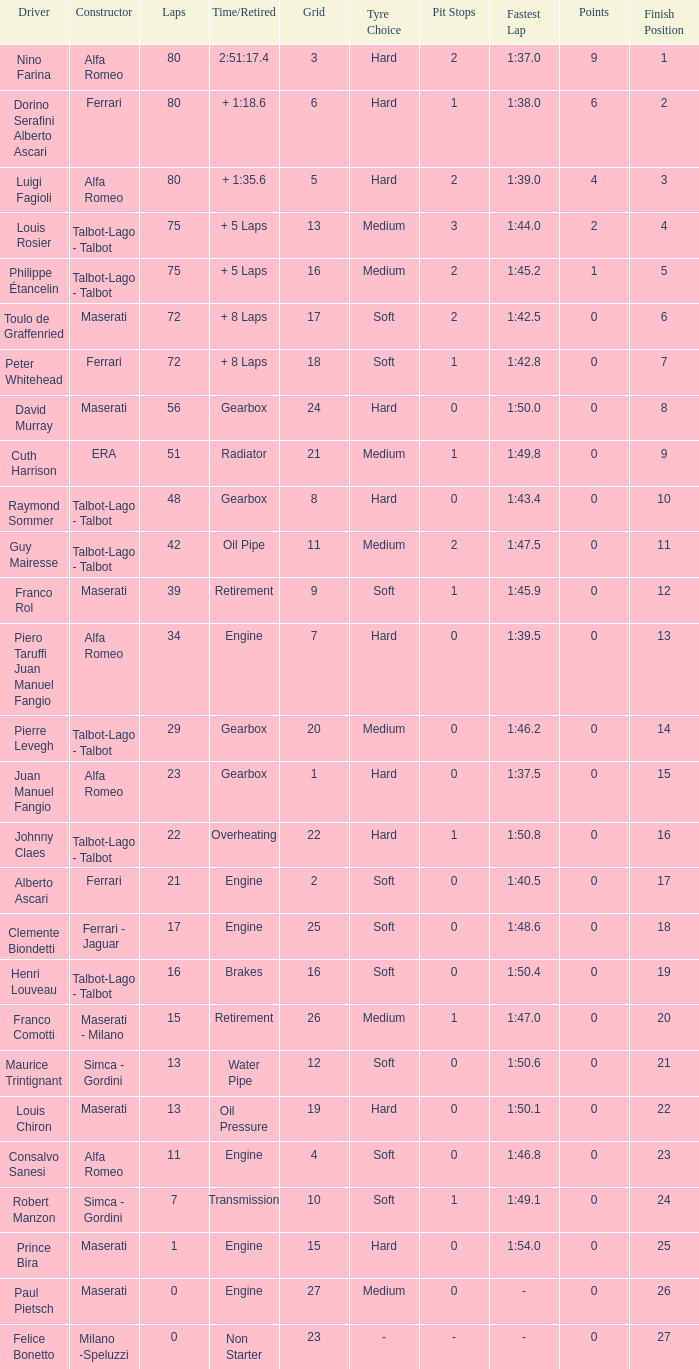Help me parse the entirety of this table. {'header': ['Driver', 'Constructor', 'Laps', 'Time/Retired', 'Grid', 'Tyre Choice', 'Pit Stops', 'Fastest Lap', 'Points', 'Finish Position'], 'rows': [['Nino Farina', 'Alfa Romeo', '80', '2:51:17.4', '3', 'Hard', '2', '1:37.0', '9', '1'], ['Dorino Serafini Alberto Ascari', 'Ferrari', '80', '+ 1:18.6', '6', 'Hard', '1', '1:38.0', '6', '2'], ['Luigi Fagioli', 'Alfa Romeo', '80', '+ 1:35.6', '5', 'Hard', '2', '1:39.0', '4', '3'], ['Louis Rosier', 'Talbot-Lago - Talbot', '75', '+ 5 Laps', '13', 'Medium', '3', '1:44.0', '2', '4'], ['Philippe Étancelin', 'Talbot-Lago - Talbot', '75', '+ 5 Laps', '16', 'Medium', '2', '1:45.2', '1', '5'], ['Toulo de Graffenried', 'Maserati', '72', '+ 8 Laps', '17', 'Soft', '2', '1:42.5', '0', '6'], ['Peter Whitehead', 'Ferrari', '72', '+ 8 Laps', '18', 'Soft', '1', '1:42.8', '0', '7'], ['David Murray', 'Maserati', '56', 'Gearbox', '24', 'Hard', '0', '1:50.0', '0', '8'], ['Cuth Harrison', 'ERA', '51', 'Radiator', '21', 'Medium', '1', '1:49.8', '0', '9'], ['Raymond Sommer', 'Talbot-Lago - Talbot', '48', 'Gearbox', '8', 'Hard', '0', '1:43.4', '0', '10'], ['Guy Mairesse', 'Talbot-Lago - Talbot', '42', 'Oil Pipe', '11', 'Medium', '2', '1:47.5', '0', '11'], ['Franco Rol', 'Maserati', '39', 'Retirement', '9', 'Soft', '1', '1:45.9', '0', '12'], ['Piero Taruffi Juan Manuel Fangio', 'Alfa Romeo', '34', 'Engine', '7', 'Hard', '0', '1:39.5', '0', '13'], ['Pierre Levegh', 'Talbot-Lago - Talbot', '29', 'Gearbox', '20', 'Medium', '0', '1:46.2', '0', '14'], ['Juan Manuel Fangio', 'Alfa Romeo', '23', 'Gearbox', '1', 'Hard', '0', '1:37.5', '0', '15'], ['Johnny Claes', 'Talbot-Lago - Talbot', '22', 'Overheating', '22', 'Hard', '1', '1:50.8', '0', '16'], ['Alberto Ascari', 'Ferrari', '21', 'Engine', '2', 'Soft', '0', '1:40.5', '0', '17'], ['Clemente Biondetti', 'Ferrari - Jaguar', '17', 'Engine', '25', 'Soft', '0', '1:48.6', '0', '18'], ['Henri Louveau', 'Talbot-Lago - Talbot', '16', 'Brakes', '16', 'Soft', '0', '1:50.4', '0', '19'], ['Franco Comotti', 'Maserati - Milano', '15', 'Retirement', '26', 'Medium', '1', '1:47.0', '0', '20'], ['Maurice Trintignant', 'Simca - Gordini', '13', 'Water Pipe', '12', 'Soft', '0', '1:50.6', '0', '21'], ['Louis Chiron', 'Maserati', '13', 'Oil Pressure', '19', 'Hard', '0', '1:50.1', '0', '22'], ['Consalvo Sanesi', 'Alfa Romeo', '11', 'Engine', '4', 'Soft', '0', '1:46.8', '0', '23'], ['Robert Manzon', 'Simca - Gordini', '7', 'Transmission', '10', 'Soft', '1', '1:49.1', '0', '24'], ['Prince Bira', 'Maserati', '1', 'Engine', '15', 'Hard', '0', '1:54.0', '0', '25'], ['Paul Pietsch', 'Maserati', '0', 'Engine', '27', 'Medium', '0', '-', '0', '26'], ['Felice Bonetto', 'Milano -Speluzzi', '0', 'Non Starter', '23', '-', '-', '-', '0', '27']]} When grid is less than 7, laps are greater than 17, and time/retired is + 1:35.6, who is the constructor? Alfa Romeo. 